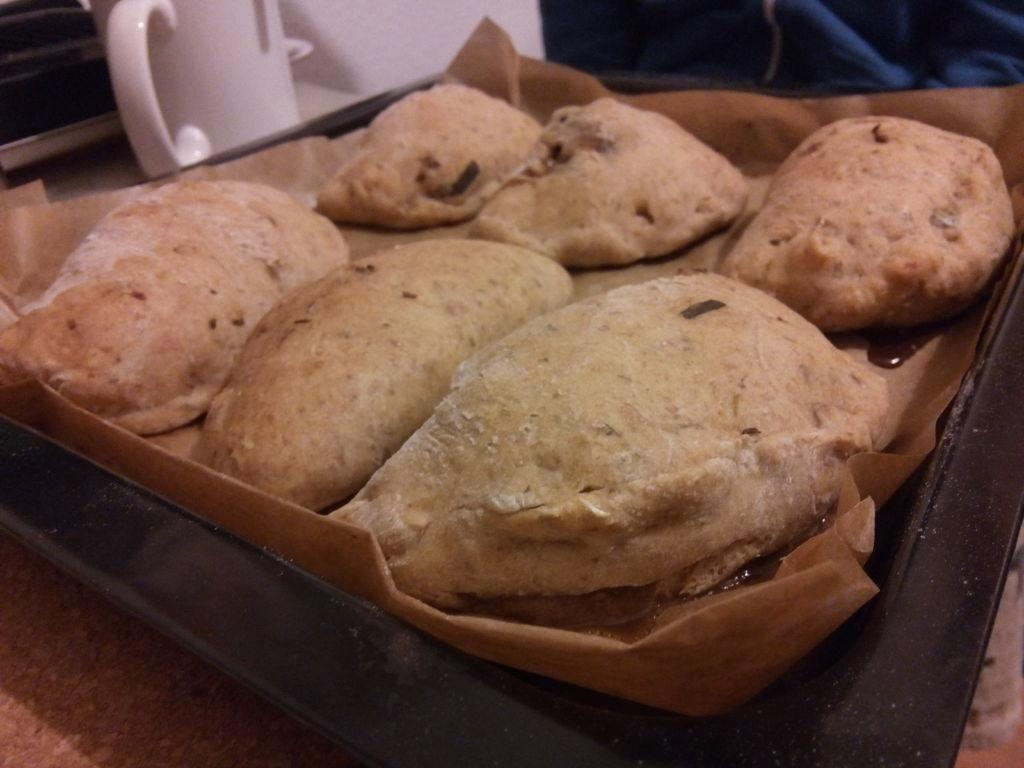What types of items are present in the image? There are food items in the image. What is the color of the plate on which the food items are placed? The plate is black in color. How does the unit feel about the pizzas in the image? There is no unit or pizzas present in the image, so it is not possible to determine how a unit might feel about pizzas. 